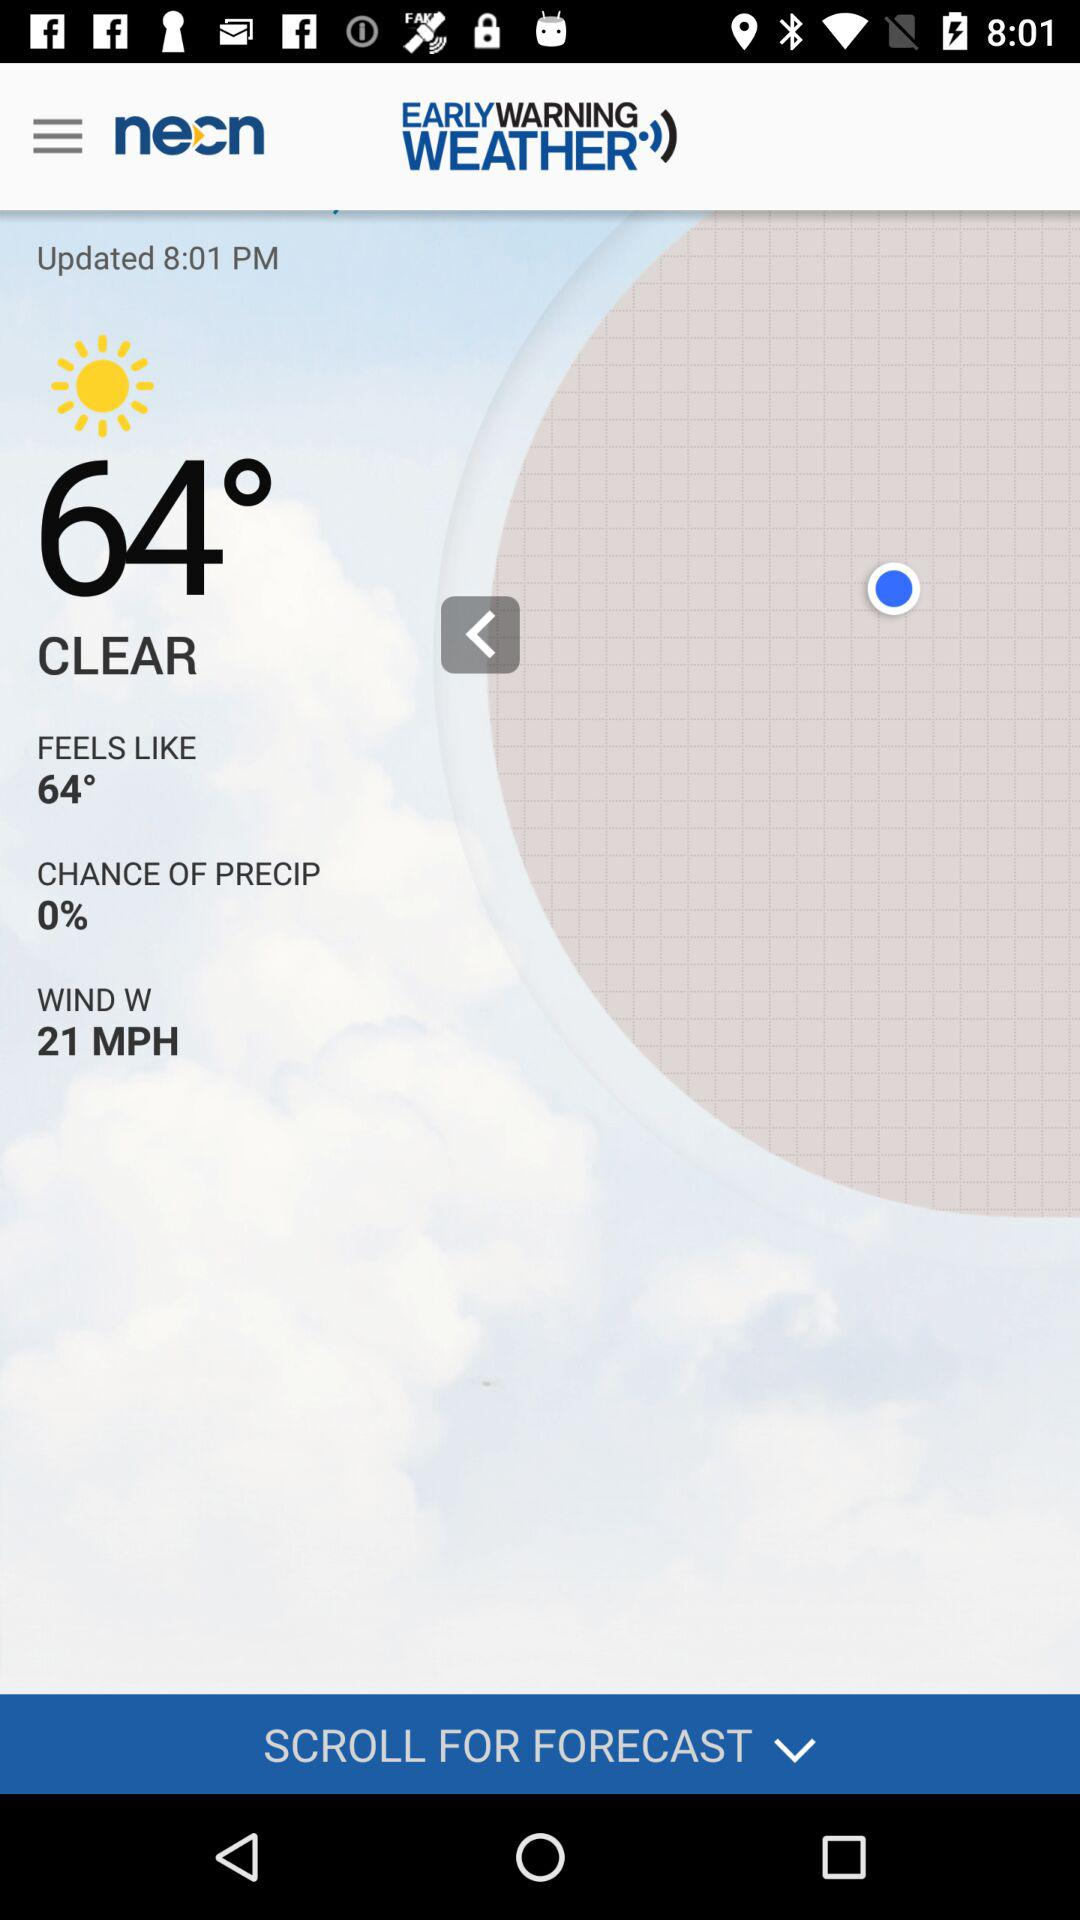Which city is the weather report for?
When the provided information is insufficient, respond with <no answer>. <no answer> 